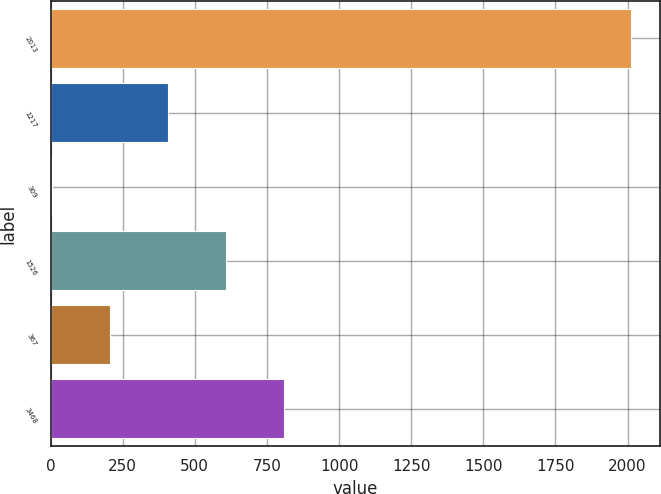Convert chart to OTSL. <chart><loc_0><loc_0><loc_500><loc_500><bar_chart><fcel>2013<fcel>1217<fcel>309<fcel>1526<fcel>367<fcel>3468<nl><fcel>2011<fcel>407<fcel>6<fcel>607.5<fcel>206.5<fcel>808<nl></chart> 